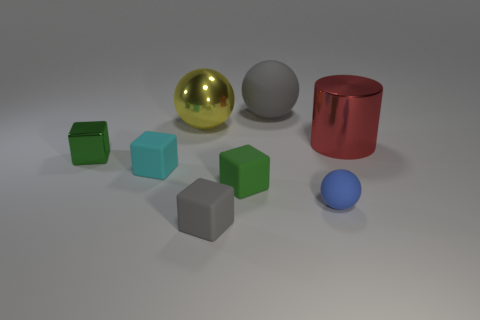There is a green shiny thing; is it the same size as the gray matte thing behind the cyan object?
Give a very brief answer. No. How many things are either green metal things or tiny metal blocks that are on the left side of the red metallic object?
Provide a short and direct response. 1. Are there more big red cylinders than cyan cylinders?
Your answer should be compact. Yes. Is there a gray sphere made of the same material as the tiny blue thing?
Ensure brevity in your answer.  Yes. There is a thing that is both to the right of the big matte object and in front of the cylinder; what is its shape?
Offer a very short reply. Sphere. What number of other things are the same shape as the green metal thing?
Keep it short and to the point. 3. The green shiny object has what size?
Give a very brief answer. Small. What number of things are tiny green rubber blocks or metallic objects?
Provide a succinct answer. 4. What size is the shiny thing right of the yellow metal thing?
Offer a very short reply. Large. What color is the tiny cube that is to the right of the shiny cube and left of the large yellow metallic object?
Offer a terse response. Cyan. 